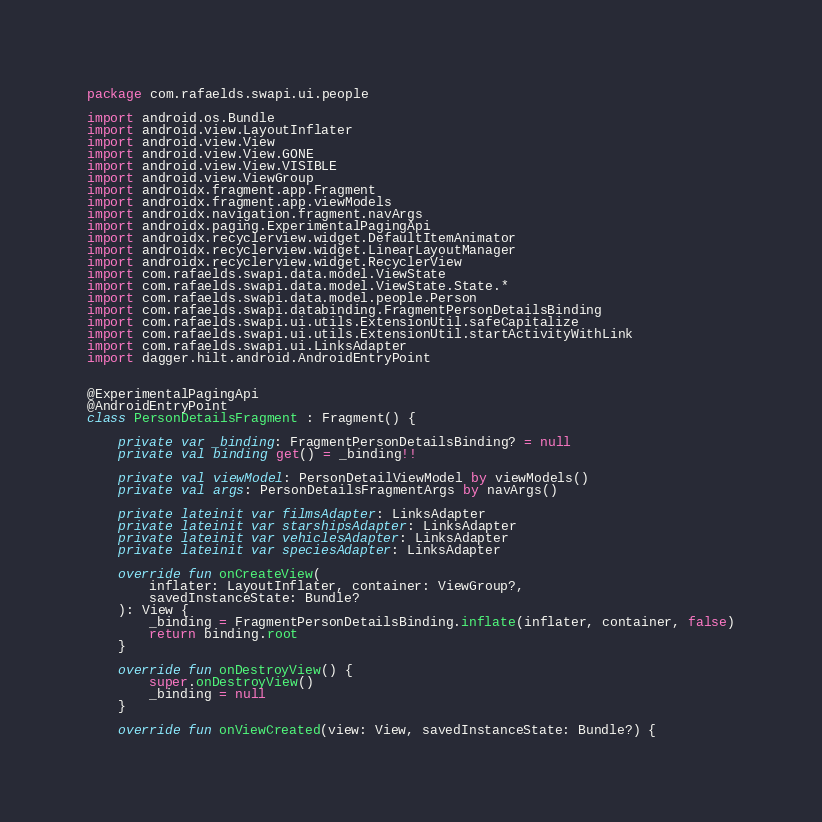Convert code to text. <code><loc_0><loc_0><loc_500><loc_500><_Kotlin_>package com.rafaelds.swapi.ui.people

import android.os.Bundle
import android.view.LayoutInflater
import android.view.View
import android.view.View.GONE
import android.view.View.VISIBLE
import android.view.ViewGroup
import androidx.fragment.app.Fragment
import androidx.fragment.app.viewModels
import androidx.navigation.fragment.navArgs
import androidx.paging.ExperimentalPagingApi
import androidx.recyclerview.widget.DefaultItemAnimator
import androidx.recyclerview.widget.LinearLayoutManager
import androidx.recyclerview.widget.RecyclerView
import com.rafaelds.swapi.data.model.ViewState
import com.rafaelds.swapi.data.model.ViewState.State.*
import com.rafaelds.swapi.data.model.people.Person
import com.rafaelds.swapi.databinding.FragmentPersonDetailsBinding
import com.rafaelds.swapi.ui.utils.ExtensionUtil.safeCapitalize
import com.rafaelds.swapi.ui.utils.ExtensionUtil.startActivityWithLink
import com.rafaelds.swapi.ui.LinksAdapter
import dagger.hilt.android.AndroidEntryPoint


@ExperimentalPagingApi
@AndroidEntryPoint
class PersonDetailsFragment : Fragment() {

    private var _binding: FragmentPersonDetailsBinding? = null
    private val binding get() = _binding!!

    private val viewModel: PersonDetailViewModel by viewModels()
    private val args: PersonDetailsFragmentArgs by navArgs()

    private lateinit var filmsAdapter: LinksAdapter
    private lateinit var starshipsAdapter: LinksAdapter
    private lateinit var vehiclesAdapter: LinksAdapter
    private lateinit var speciesAdapter: LinksAdapter

    override fun onCreateView(
        inflater: LayoutInflater, container: ViewGroup?,
        savedInstanceState: Bundle?
    ): View {
        _binding = FragmentPersonDetailsBinding.inflate(inflater, container, false)
        return binding.root
    }

    override fun onDestroyView() {
        super.onDestroyView()
        _binding = null
    }

    override fun onViewCreated(view: View, savedInstanceState: Bundle?) {</code> 